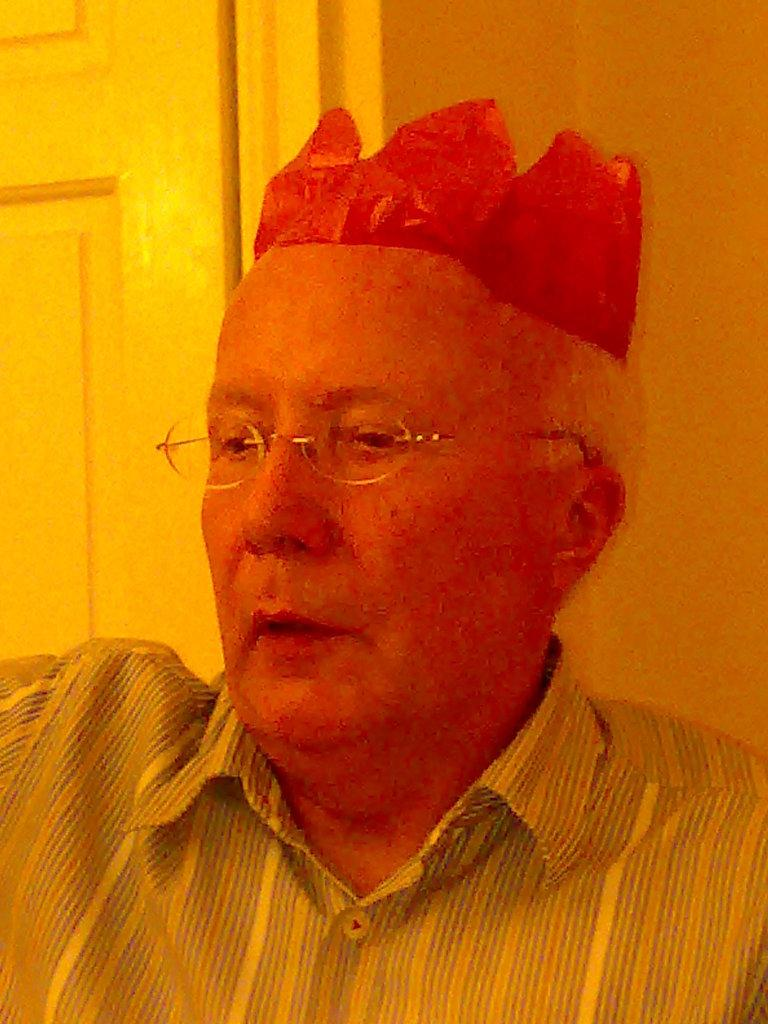What can be seen in the image? There is a person in the image. Can you describe the person's clothing? The person is wearing a shirt. Are there any accessories visible on the person? Yes, the person is wearing spectacles. What is on the person's head? There is a red-colored object on the person's head. What can be seen in the background of the image? There is a wall and a door in the background of the image. What type of desk is the person using in the image? There is no desk present in the image. How many tickets does the person have in their hand in the image? There is no ticket visible in the image. 